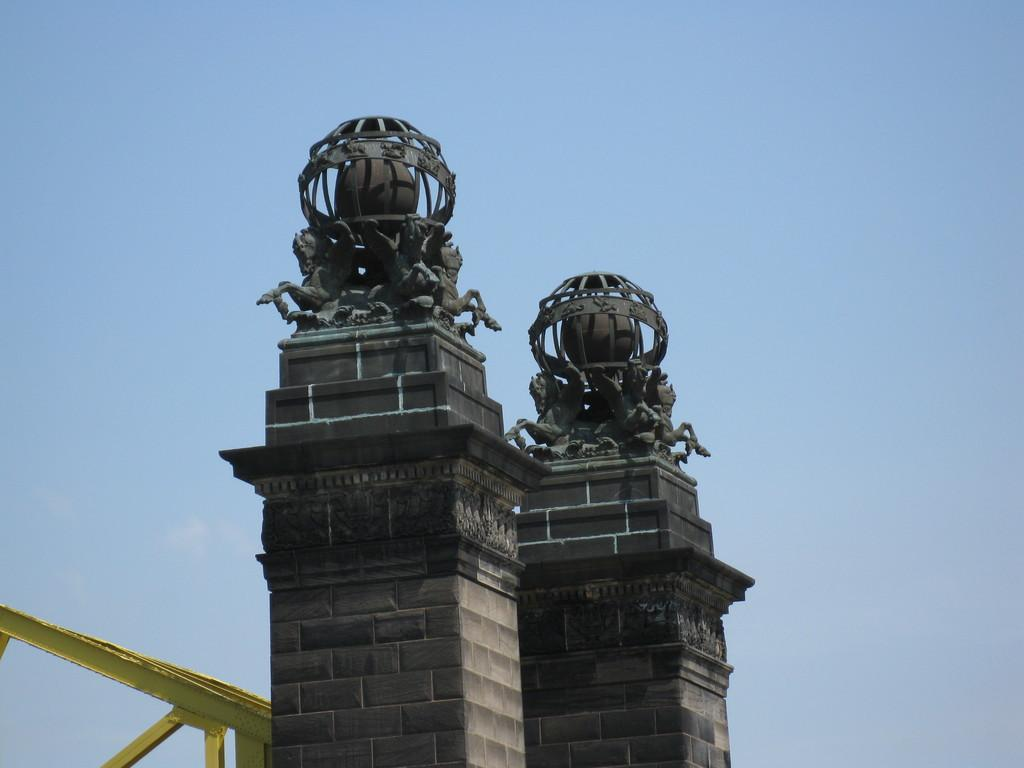What is on the pillars in the image? There is a sculpture on the pillars in the image. What can be seen on the left side of the image? There are metal rods on the left side of the image. What color is the sky in the image? The sky is blue in the image. Can you tell me how many horses are depicted in the image? There are no horses present in the image. What type of stove is visible in the image? There is no stove present in the image. 